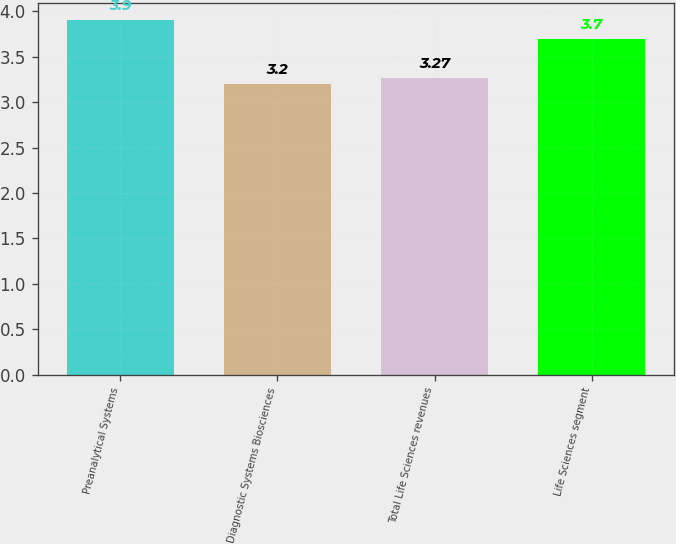Convert chart. <chart><loc_0><loc_0><loc_500><loc_500><bar_chart><fcel>Preanalytical Systems<fcel>Diagnostic Systems Biosciences<fcel>Total Life Sciences revenues<fcel>Life Sciences segment<nl><fcel>3.9<fcel>3.2<fcel>3.27<fcel>3.7<nl></chart> 